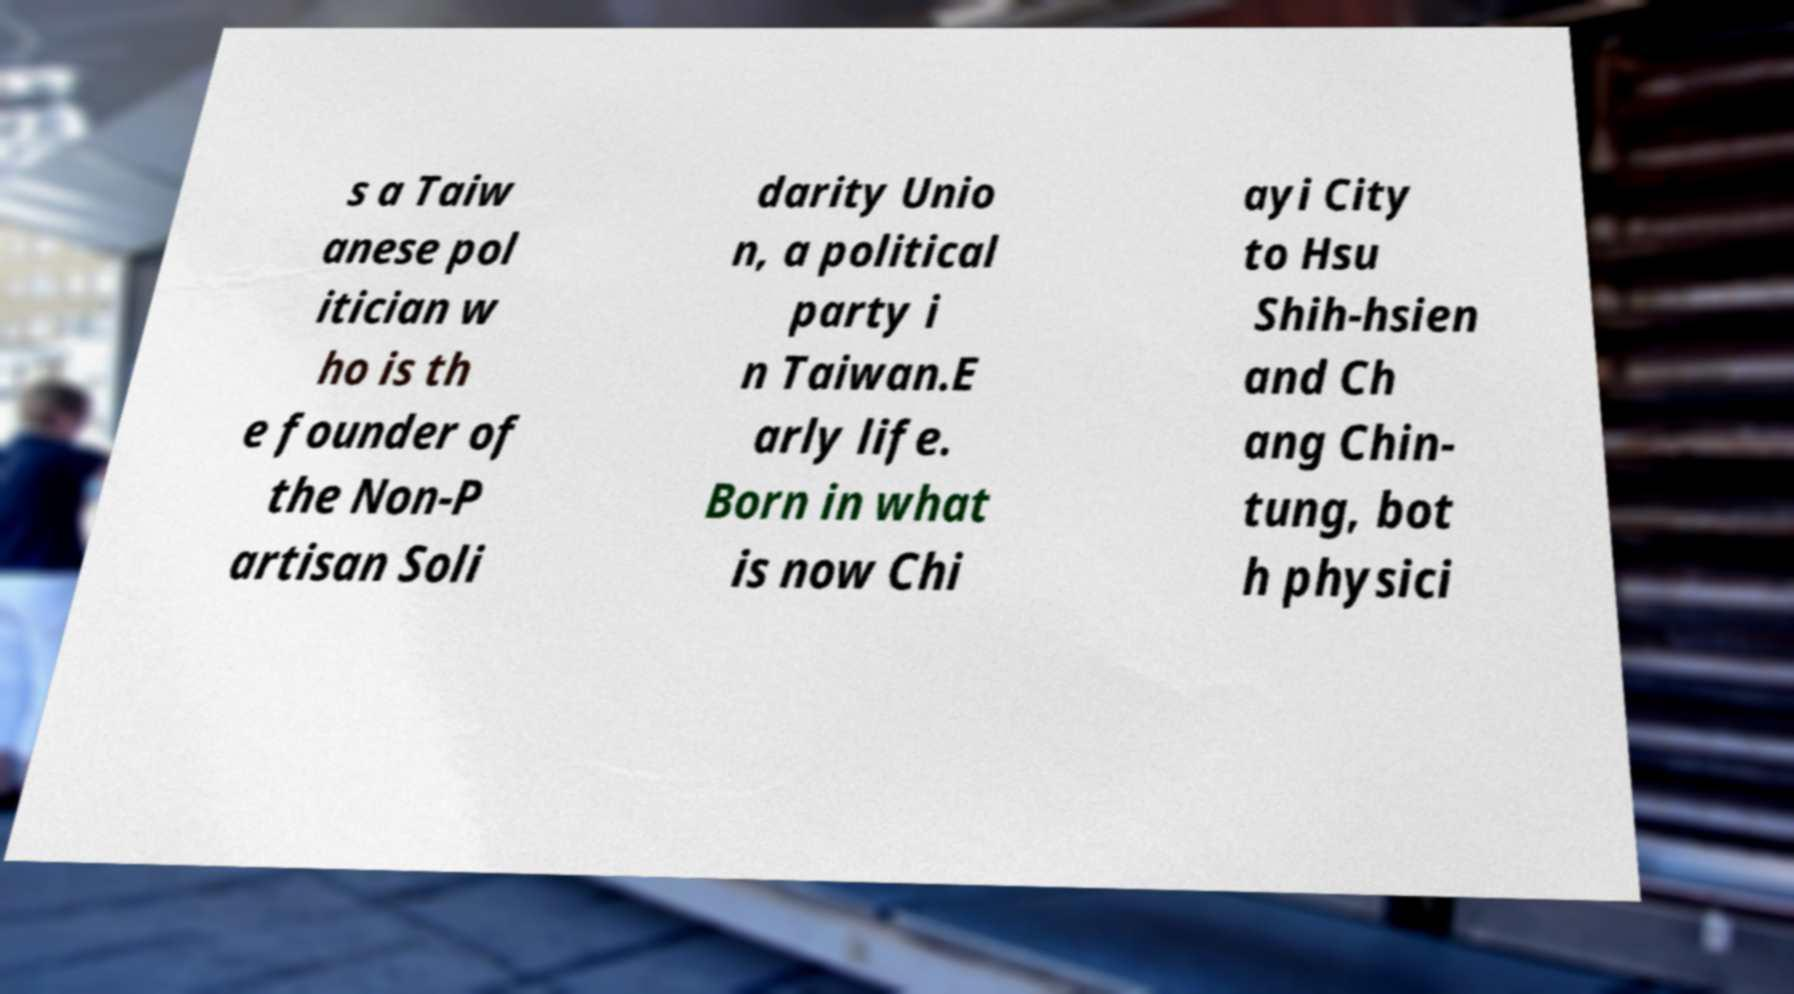Could you assist in decoding the text presented in this image and type it out clearly? s a Taiw anese pol itician w ho is th e founder of the Non-P artisan Soli darity Unio n, a political party i n Taiwan.E arly life. Born in what is now Chi ayi City to Hsu Shih-hsien and Ch ang Chin- tung, bot h physici 